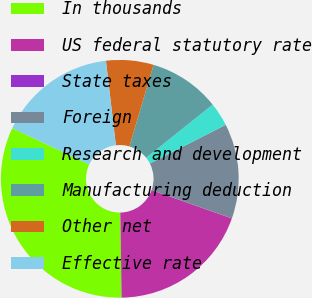<chart> <loc_0><loc_0><loc_500><loc_500><pie_chart><fcel>In thousands<fcel>US federal statutory rate<fcel>State taxes<fcel>Foreign<fcel>Research and development<fcel>Manufacturing deduction<fcel>Other net<fcel>Effective rate<nl><fcel>32.25%<fcel>19.35%<fcel>0.01%<fcel>12.9%<fcel>3.23%<fcel>9.68%<fcel>6.45%<fcel>16.13%<nl></chart> 